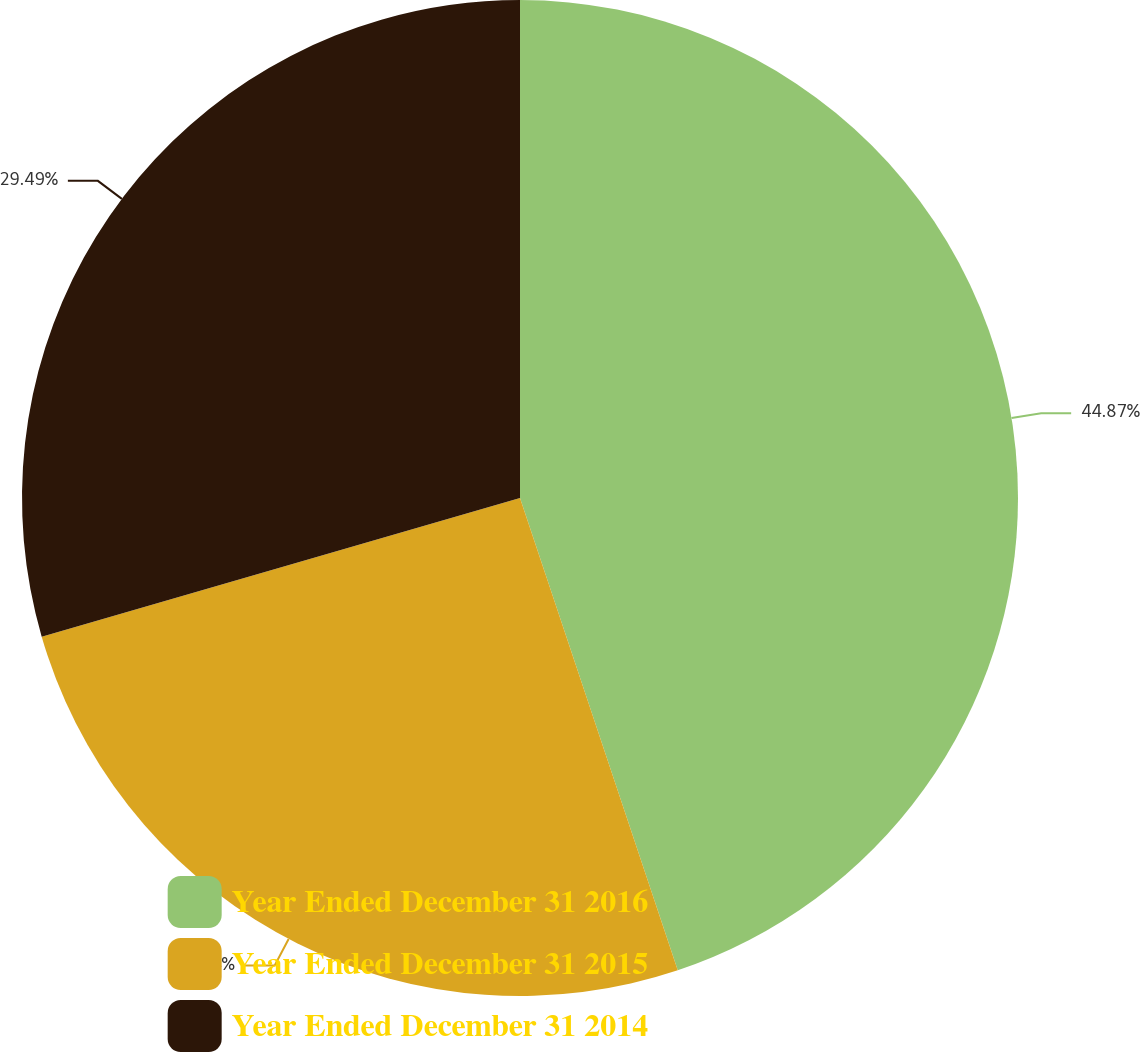Convert chart. <chart><loc_0><loc_0><loc_500><loc_500><pie_chart><fcel>Year Ended December 31 2016<fcel>Year Ended December 31 2015<fcel>Year Ended December 31 2014<nl><fcel>44.87%<fcel>25.64%<fcel>29.49%<nl></chart> 